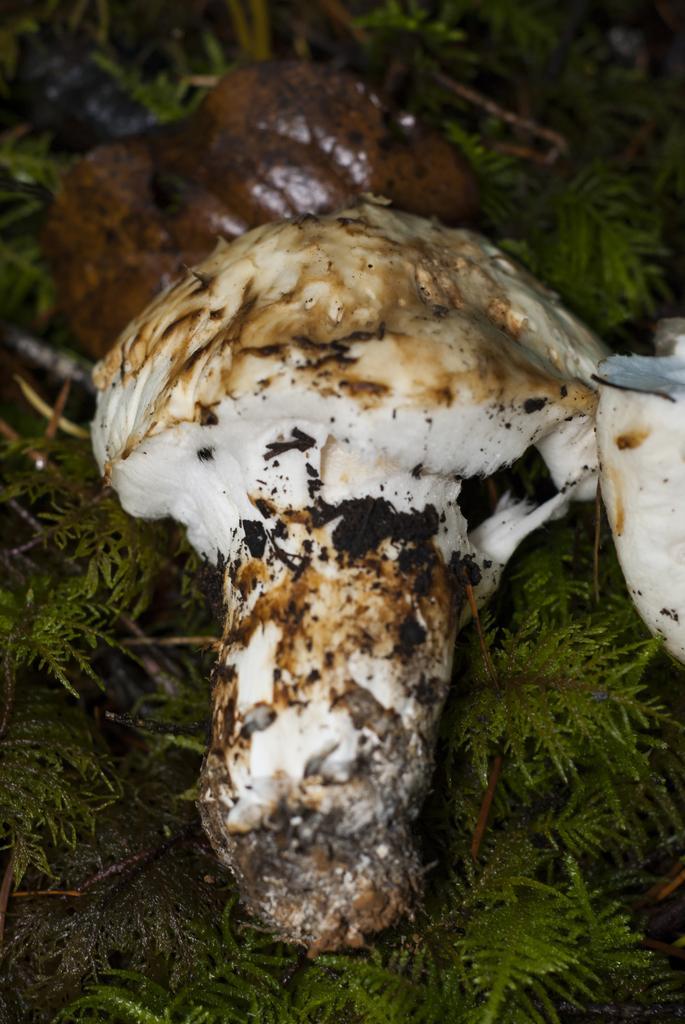How would you summarize this image in a sentence or two? In the image we can see a mushroom. Behind the mushroom there is grass. 